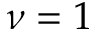<formula> <loc_0><loc_0><loc_500><loc_500>\nu = 1</formula> 